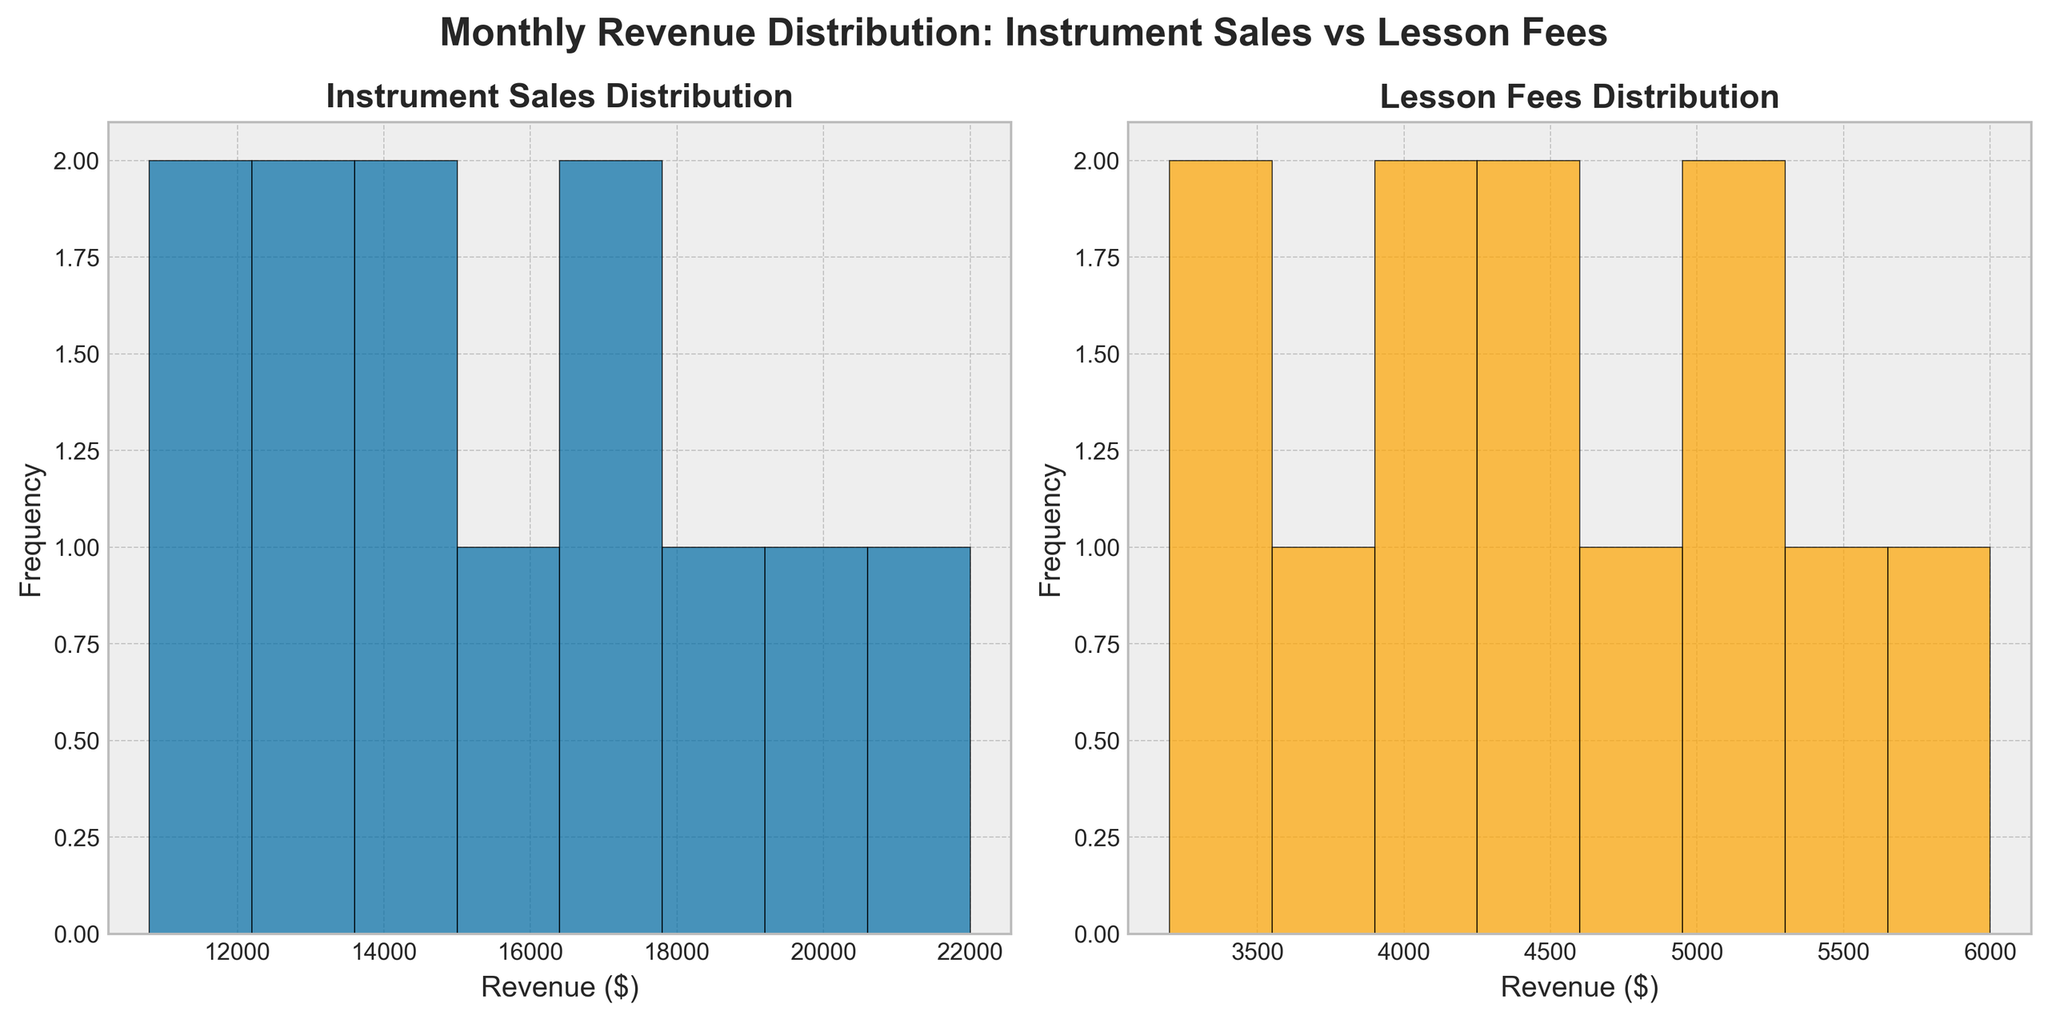What is the title of the figure? The title of the figure is placed above the subplots and it summarizes the overall content being visualized; it reads "Monthly Revenue Distribution: Instrument Sales vs Lesson Fees."
Answer: Monthly Revenue Distribution: Instrument Sales vs Lesson Fees How many months have Lesson Fees between $3000 and $4000? To answer this, count the number of bars between $3000 and $4000 in the Lesson Fees histogram subplot. There appear to be 2 bars in this range.
Answer: 2 Which type of revenue has a higher maximum value and what is it? By comparing the highest values in both histograms, the maximum value for Instrument Sales is $22000 in December, whereas the maximum for Lesson Fees is $6000, also in December. Therefore, Instrument Sales have a higher maximum value.
Answer: Instrument Sales, $22000 Are there more months with Instrument Sales above $15000 or Lesson Fees above $4500? Instrument Sales: Count the bars in the Instrument Sales histogram that are above $15000 (4 bars). Lesson Fees: Count the bars in the Lesson Fees histogram that are above $4500 (5 bars). Lesson Fees has more months above its threshold.
Answer: Lesson Fees What's the range of the revenue for Instrument Sales? Identify the minimum and maximum revenues for Instrument Sales, which are $10800 and $22000 respectively. Thus, the range is $22000 - $10800 = $11200.
Answer: $11200 How would you describe the skewness of the distribution of Lesson Fees? The skewness of the distribution can be observed from the Lesson Fees histogram. The histogram shows a concentration of frequencies towards the lower revenue bins, indicating a right skew (positively skewed).
Answer: Right skew What is the average revenue difference between Instrument Sales and Lesson Fees? Calculate the mean for both Instrument Sales and Lesson Fees, then find the difference. Mean Instrument Sales: (12500 + 10800 + 11200 + 13500 + 15000 + 14200 + 13800 + 16500 + 18000 + 17200 + 19500 + 22000)/12 = 15700. Mean Lesson Fees: (3200 + 3500 + 3800 + 4100 + 4300 + 4500 + 4200 + 4800 + 5200 + 5000 + 5500 + 6000)/12 = 4500. Difference: 15700 - 4500 = 11200.
Answer: $11200 Does either histogram show any months with the same revenue value? Examine both histograms for bars at the same revenue value. It seems there are no bars that align exactly with the same number in both histograms.
Answer: No Which month shows the highest revenue for both Instrument Sales and Lesson Fees? From the data, December shows the highest revenue values, with $22000 for Instrument Sales and $6000 for Lesson Fees.
Answer: December 